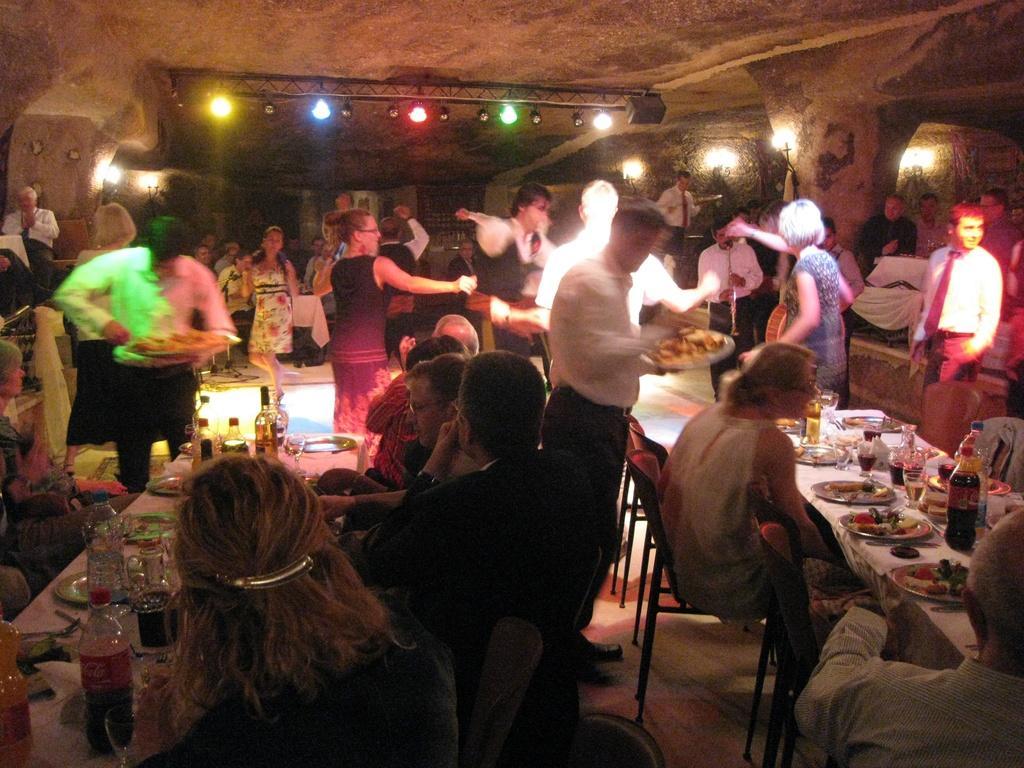Can you describe this image briefly? In this image we can see few people are sitting on the chairs. There are tables. On the tables we can see clothes, plates, bottles, glasses, spoons, and food. There are few people standing on the floor. In the background we can see lights and wall. 